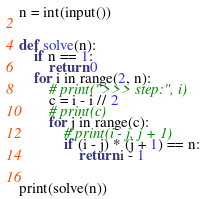<code> <loc_0><loc_0><loc_500><loc_500><_Python_>n = int(input())


def solve(n):
    if n == 1:
        return 0
    for i in range(2, n):
        # print(">>> step:", i)
        c = i - i // 2
        # print(c)
        for j in range(c):
            # print(i - j, j + 1)
            if (i - j) * (j + 1) == n:
                return i - 1


print(solve(n))

</code> 